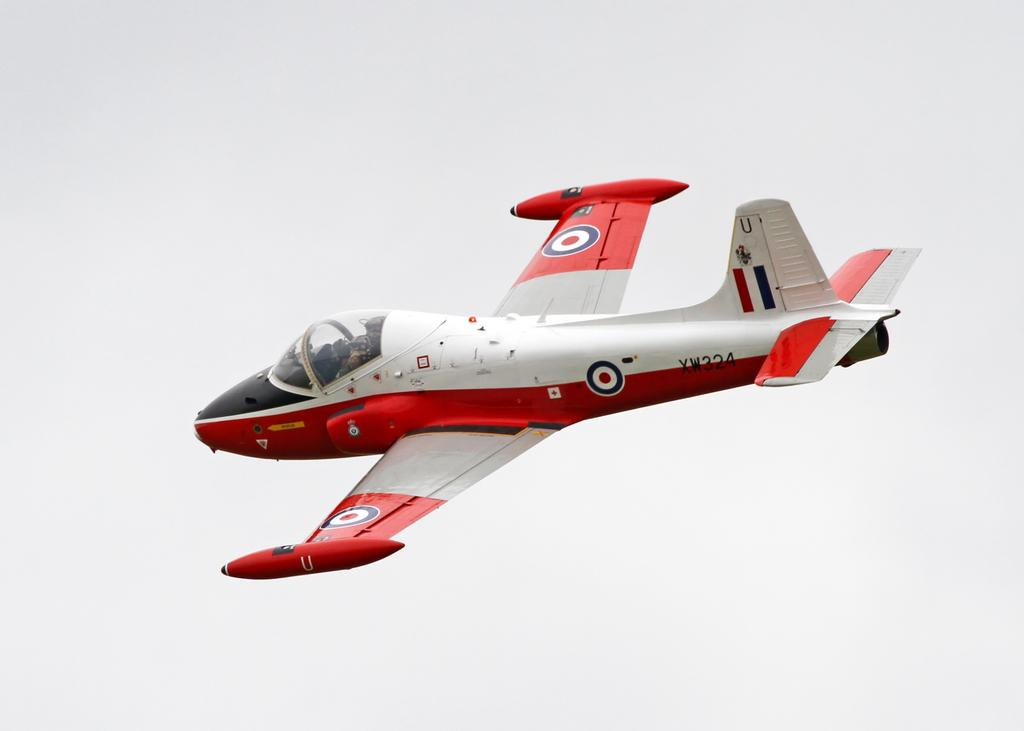What is the main subject of the image? The main subject of the image is an airplane. What is the airplane doing in the image? The airplane is flying in the image. What can be seen in the background of the image? The sky is visible in the background of the image. What type of plantation can be seen near the airplane in the image? There is no plantation present in the image; it only features an airplane flying in the sky. 